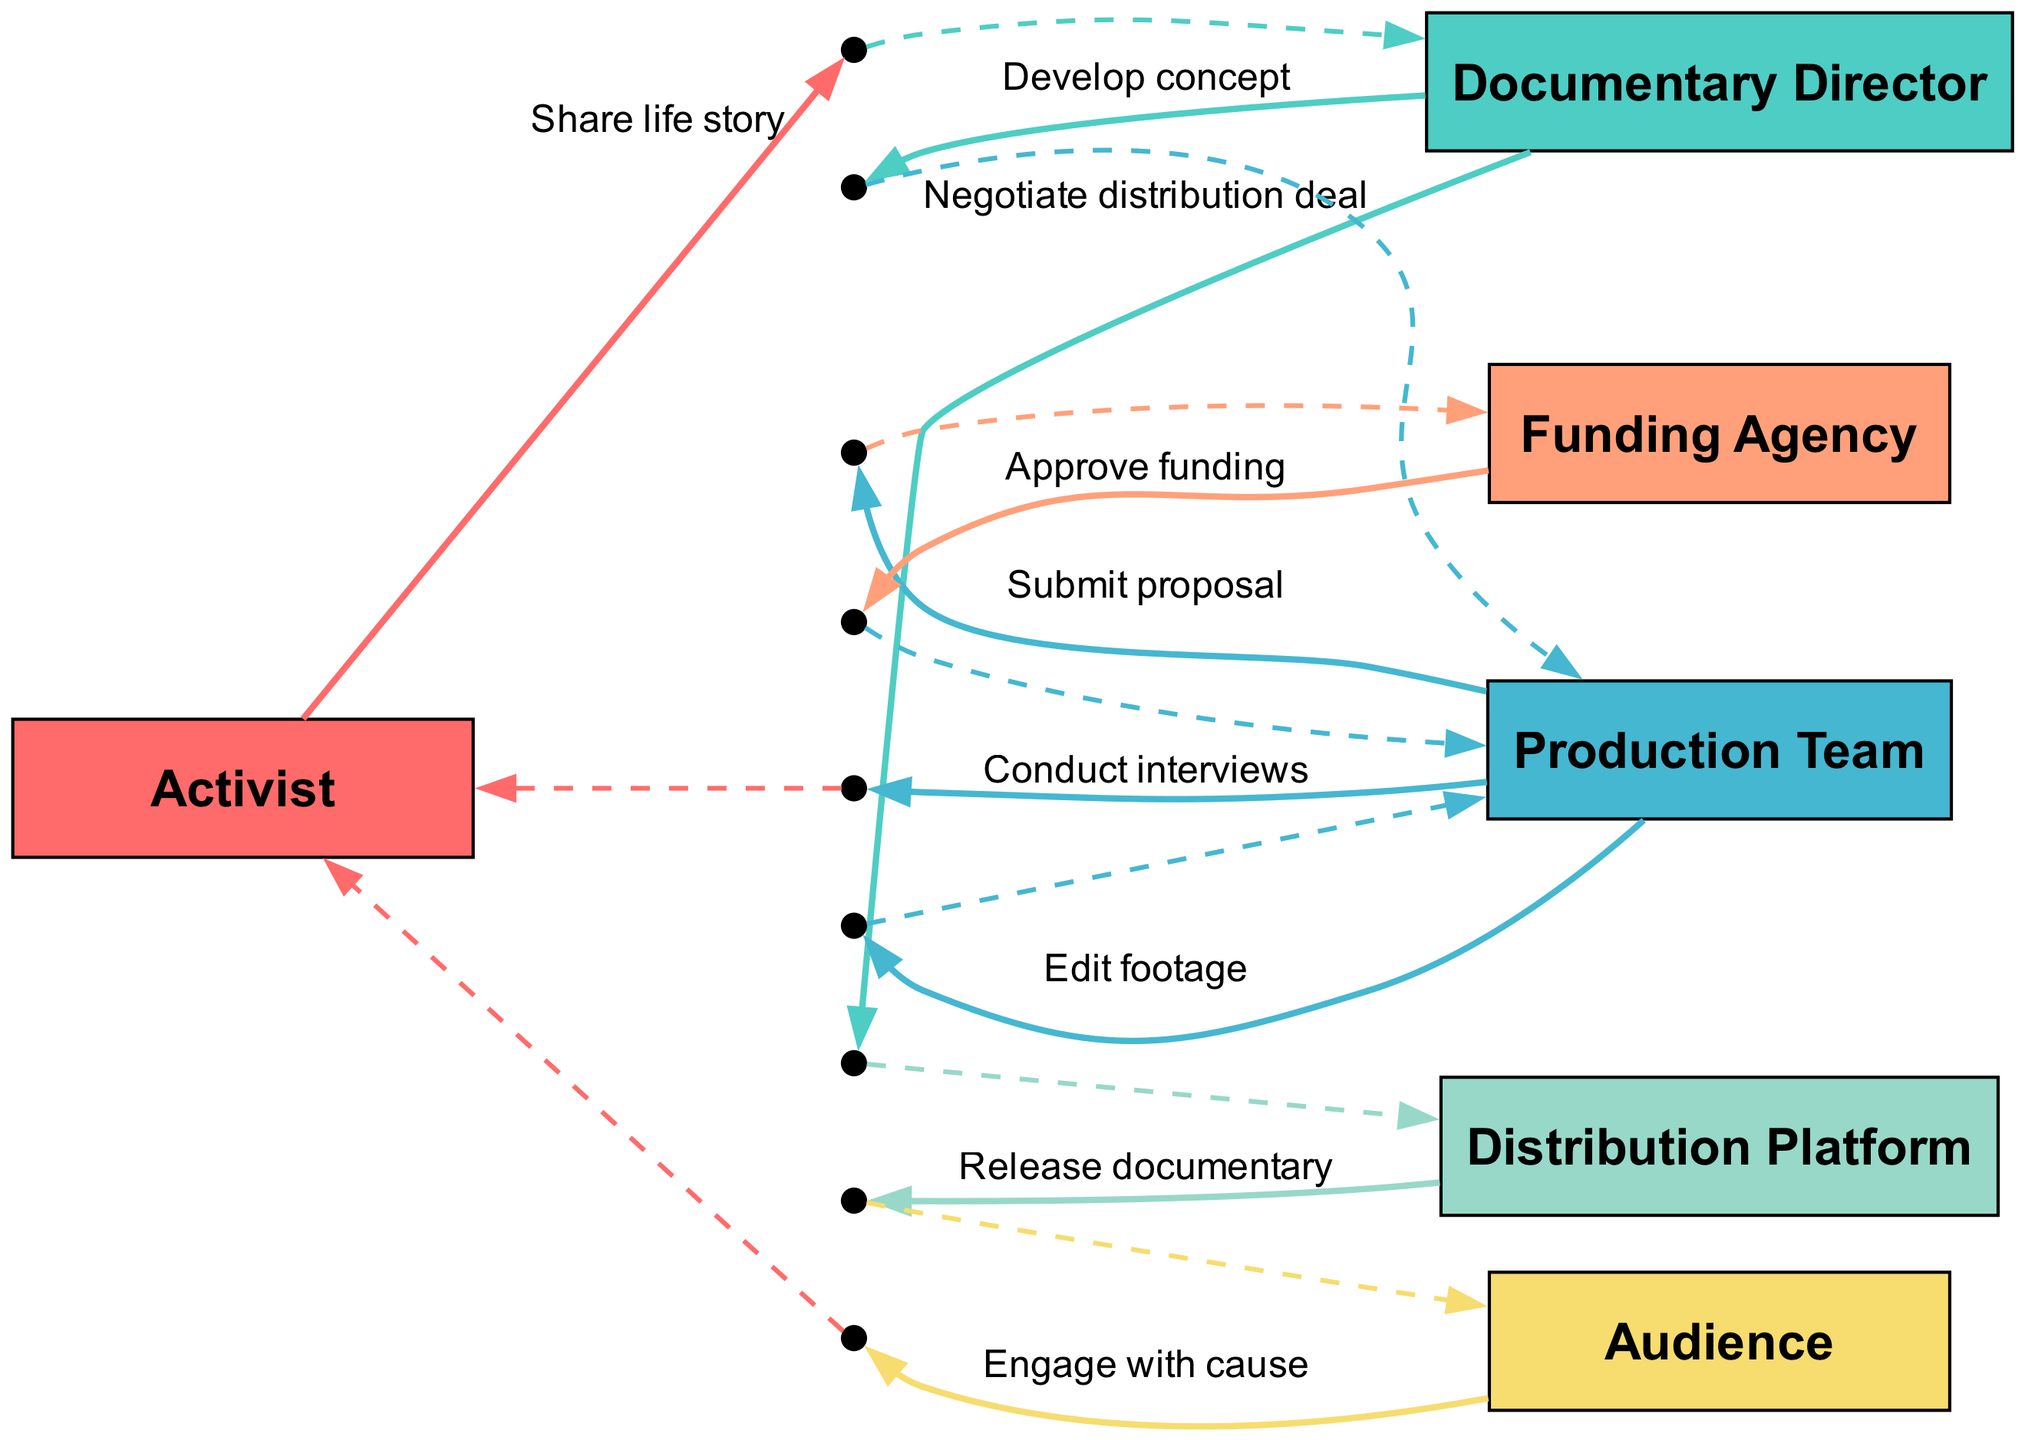What is the first action in the sequence? The first action in the sequence, as indicated by the arrow from the Activist to the Documentary Director, is "Share life story." This can be confirmed by looking at the first entry in the sequence list.
Answer: Share life story How many actors are involved in this documentary production process? The diagram lists six actors: Activist, Documentary Director, Production Team, Funding Agency, Distribution Platform, and Audience. Therefore, counting each distinct actor shows there are a total of six.
Answer: 6 Which actor negotiates the distribution deal? The sequence shows that the Documentary Director is responsible for negotiating the distribution deal, as indicated by the directed edge from the Documentary Director to the Distribution Platform with the action labeled "Negotiate distribution deal."
Answer: Documentary Director What action occurs after the funding approval? Following the approval of funding which is indicated by the edge from Funding Agency to Production Team, the next action is to "Conduct interviews" as shown by the directed edge from Production Team to Activist.
Answer: Conduct interviews Who engages with the cause at the end of the sequence? The last action in the sequence is indicated by the directed edge from the Audience to the Activist, labeled "Engage with cause," meaning that the Audience is the one that engages with the cause.
Answer: Audience How does the Production Team interact with itself during the process? The interaction occurs when the Production Team performs the action labeled "Edit footage," represented as a self-loop in the sequence diagram, indicating an internal process within the Production Team.
Answer: Edit footage What is the action taken by the Production Team towards the Funding Agency? The action taken by the Production Team towards the Funding Agency is "Submit proposal," as shown by the directed edge in the sequence. This is the proposal stage for funding and comes before funding is approved.
Answer: Submit proposal What is the relationship between the Distribution Platform and the Audience? The relationship is represented by the directed edge from Distribution Platform to Audience, where the action described is "Release documentary," signifying that the Distribution Platform is responsible for releasing the documentary to the Audience.
Answer: Release documentary How many steps are there from the Activist to the Audience? The sequence shows a total of five distinct steps from the Activist, which includes sharing the life story, conducting interviews, editing footage, negotiating the distribution deal, and releasing the documentary to the Audience.
Answer: 5 